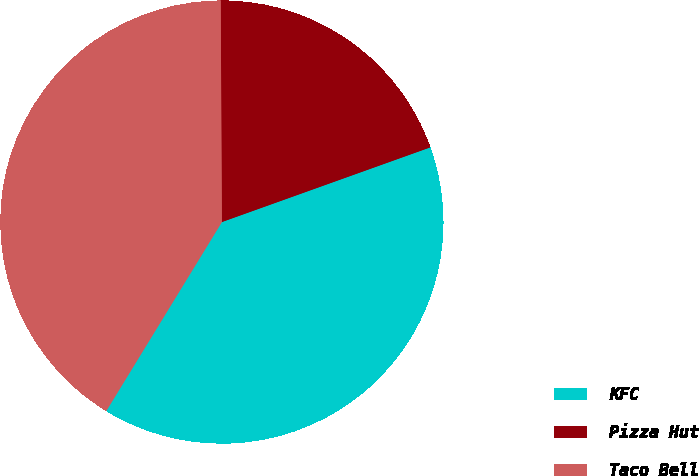Convert chart. <chart><loc_0><loc_0><loc_500><loc_500><pie_chart><fcel>KFC<fcel>Pizza Hut<fcel>Taco Bell<nl><fcel>39.22%<fcel>19.61%<fcel>41.18%<nl></chart> 